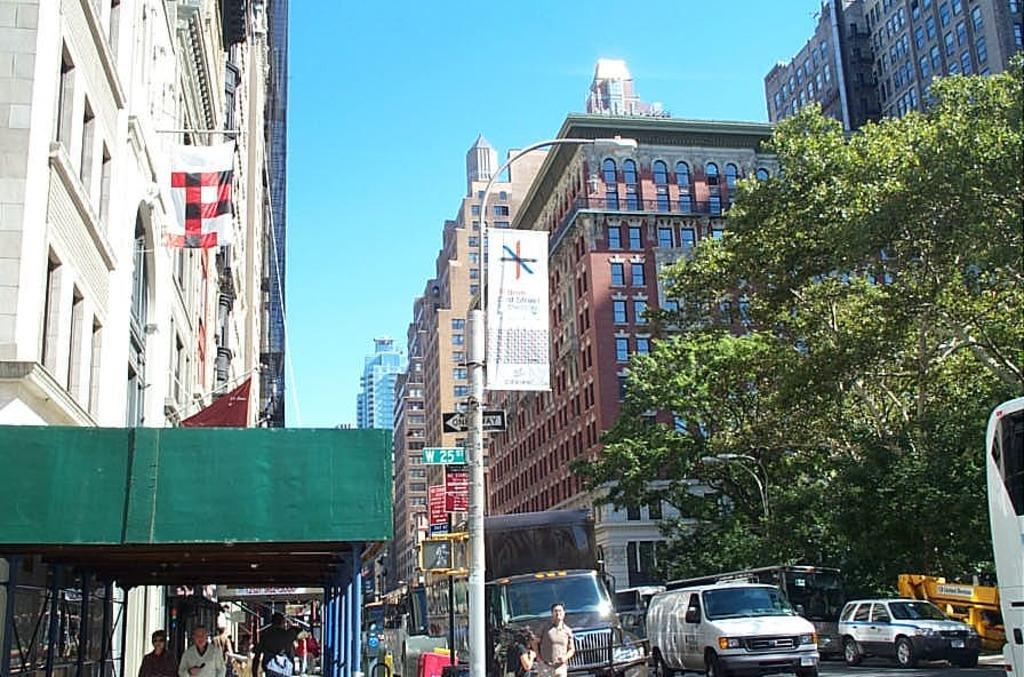Please provide a concise description of this image. In this image there are vehicles moving on the road, on the right side there is a tree, on either side of the road there are buildings, on the left side people are walking, in the background there is a blue sky. 